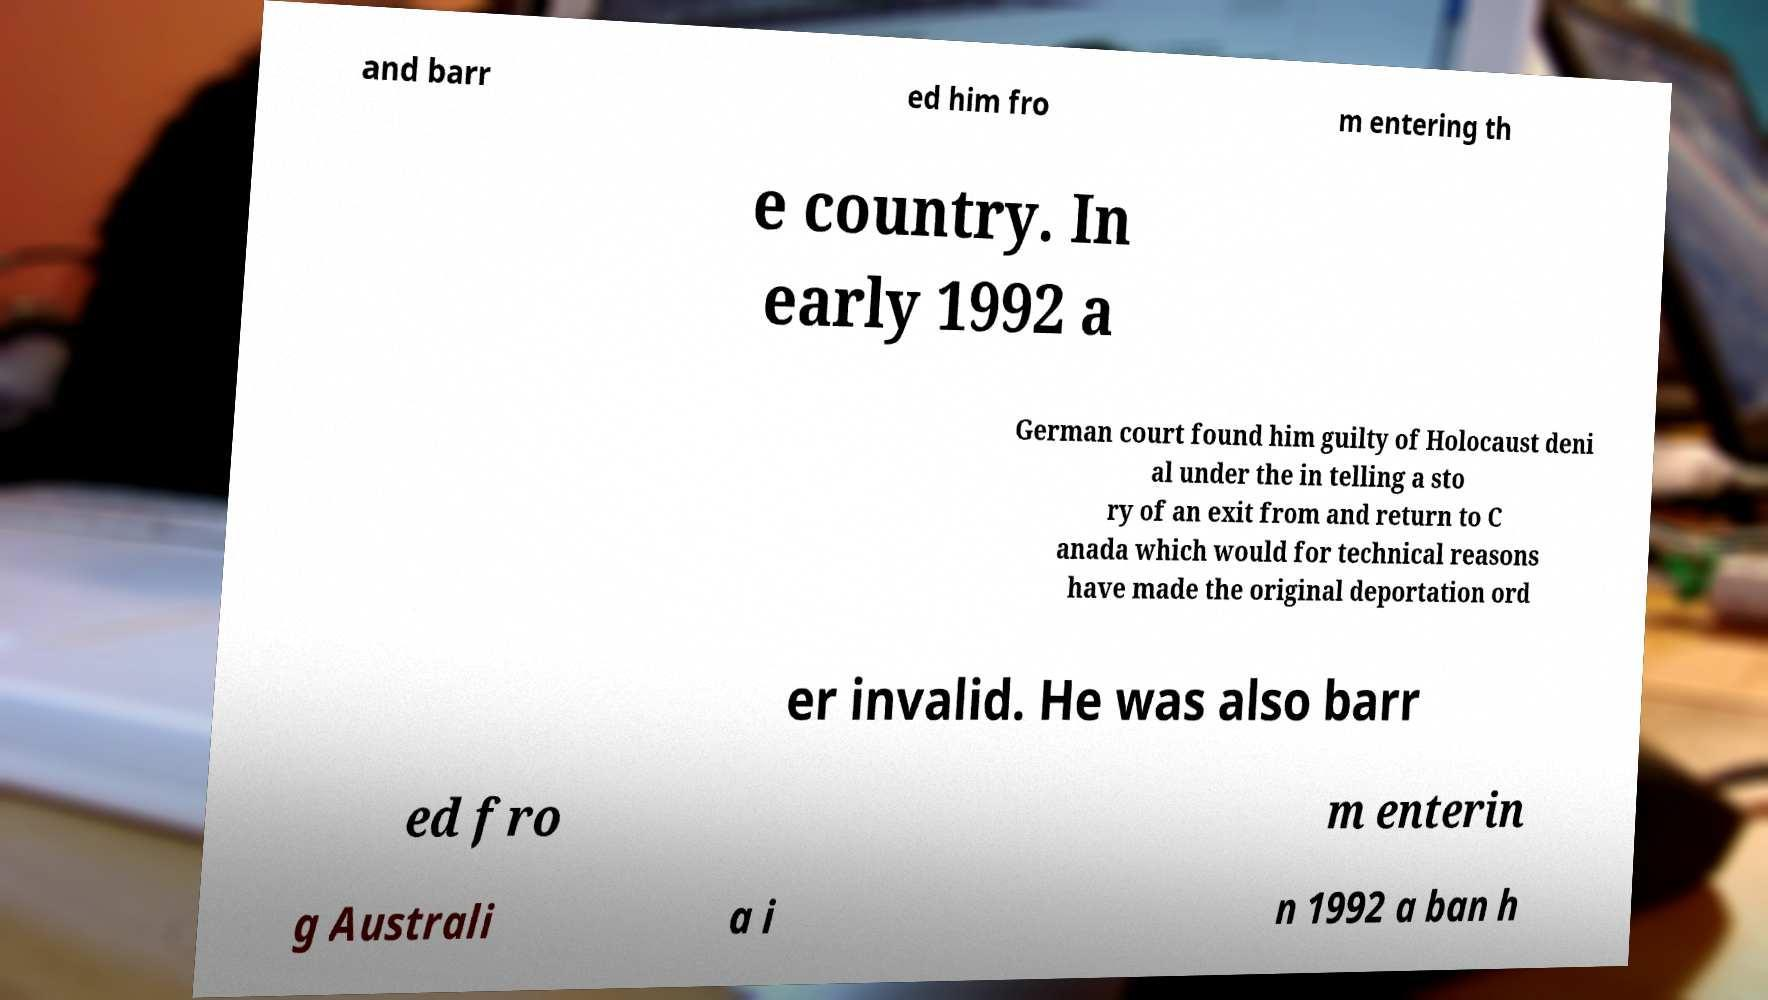Please identify and transcribe the text found in this image. and barr ed him fro m entering th e country. In early 1992 a German court found him guilty of Holocaust deni al under the in telling a sto ry of an exit from and return to C anada which would for technical reasons have made the original deportation ord er invalid. He was also barr ed fro m enterin g Australi a i n 1992 a ban h 